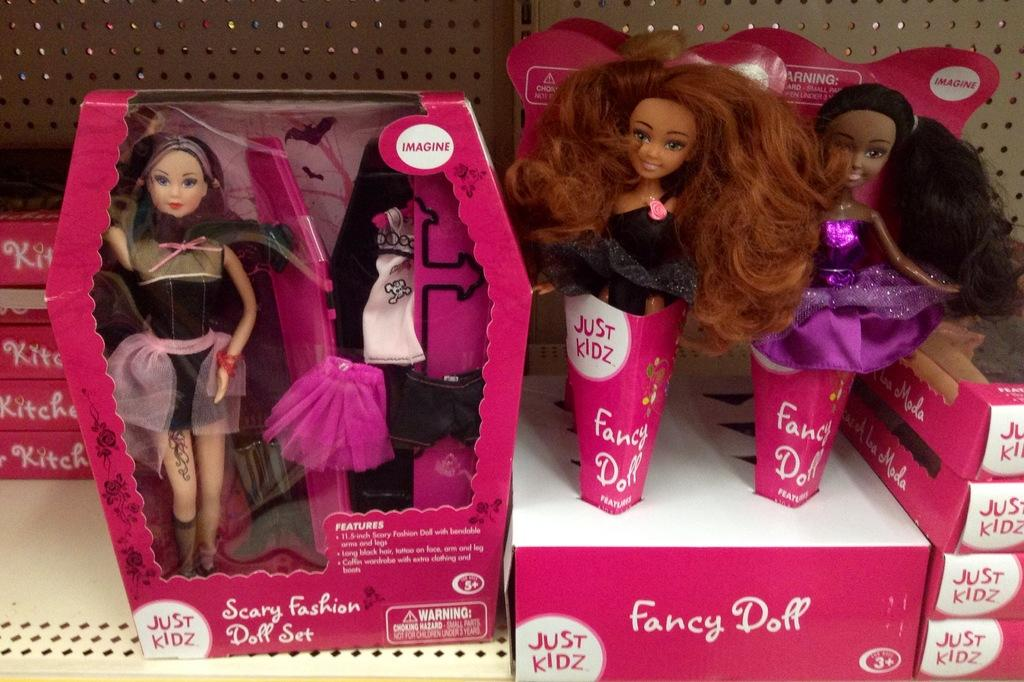What type of objects are in the image? There are dolls and boxes in the image. Can you describe the boxes in the image? The boxes are pink in color and are in an iron rack. Where are the brothers and the fireman in the image? There are no brothers or firemen present in the image. What type of cannon is used by the dolls in the image? There is no cannon present in the image. 